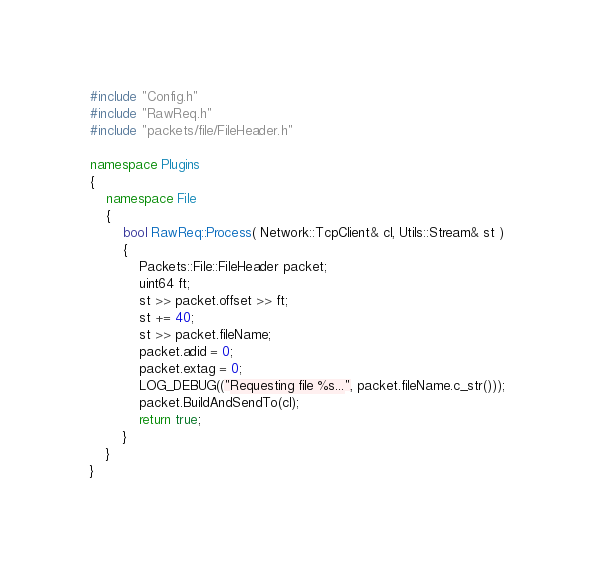Convert code to text. <code><loc_0><loc_0><loc_500><loc_500><_C++_>#include "Config.h"
#include "RawReq.h"
#include "packets/file/FileHeader.h"

namespace Plugins
{
	namespace File
	{
		bool RawReq::Process( Network::TcpClient& cl, Utils::Stream& st )
		{
			Packets::File::FileHeader packet;
			uint64 ft;
			st >> packet.offset >> ft;
			st += 40;
			st >> packet.fileName;
			packet.adid = 0;
			packet.extag = 0;
			LOG_DEBUG(("Requesting file %s...", packet.fileName.c_str()));
			packet.BuildAndSendTo(cl);
			return true;
		}
	}
}
</code> 